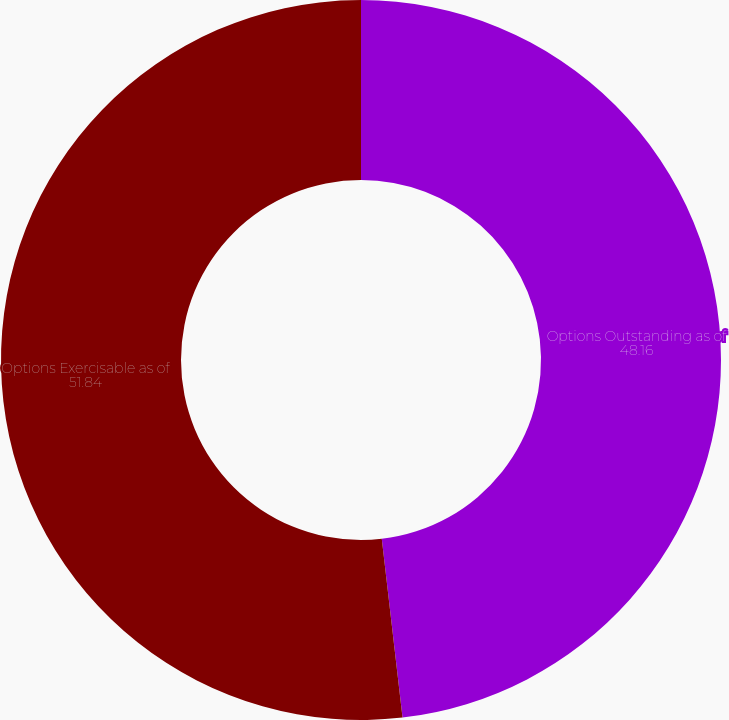<chart> <loc_0><loc_0><loc_500><loc_500><pie_chart><fcel>Options Outstanding as of<fcel>Options Exercisable as of<nl><fcel>48.16%<fcel>51.84%<nl></chart> 